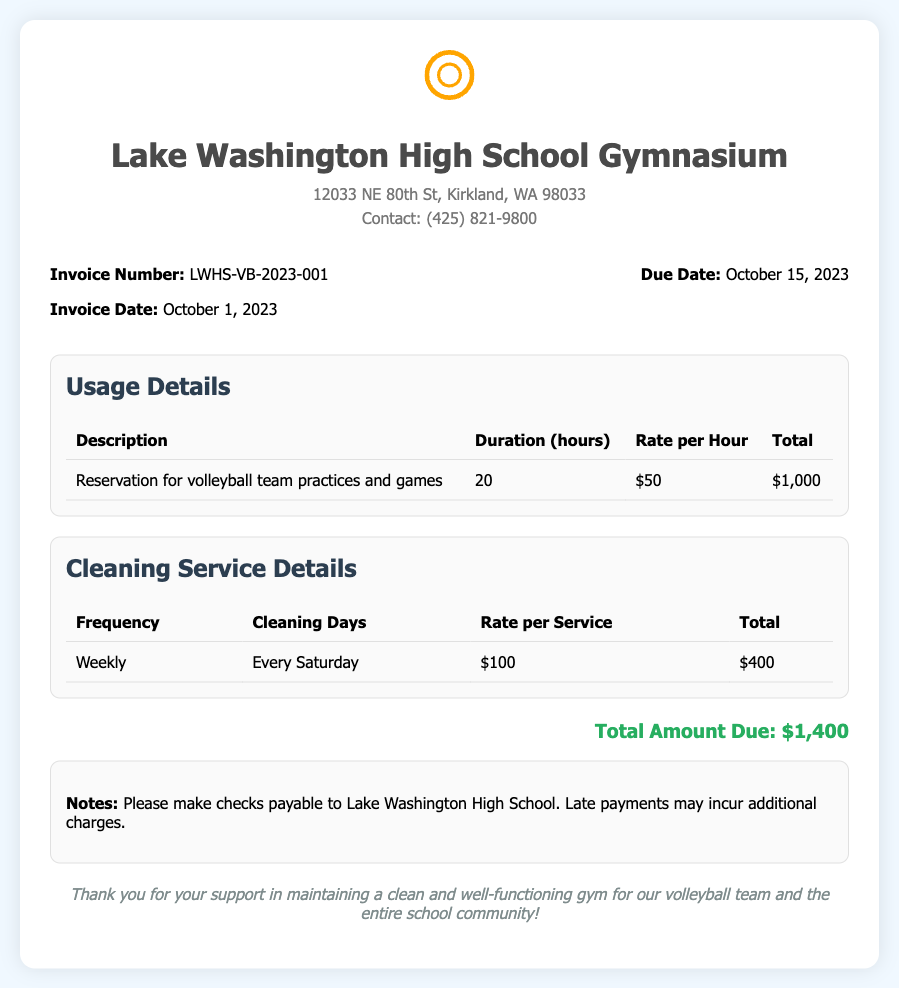what is the invoice number? The invoice number is found in the invoice details section, which states "Invoice Number: LWHS-VB-2023-001."
Answer: LWHS-VB-2023-001 what is the total amount due? The total amount due is summarized in the final section, stating "Total Amount Due: $1,400."
Answer: $1,400 how much is the rate per hour for usage? The rate per hour for usage is found in the usage details table, which indicates "Rate per Hour: $50."
Answer: $50 what is the cleaning service frequency? The cleaning service frequency is mentioned in the cleaning service details table, stating "Frequency: Weekly."
Answer: Weekly how many cleaning days are there? The number of cleaning days is specified in the cleaning service details table, stating "Cleaning Days: Every Saturday."
Answer: Every Saturday what is the duration of usage for practices? The duration for usage of the practices is listed as "Duration: 20 hours" in the usage details section.
Answer: 20 hours when is the due date for the invoice? The due date for the invoice is marked in the invoice details section as "Due Date: October 15, 2023."
Answer: October 15, 2023 how many times will the gym be cleaned in total? The cleaning service frequency indicates weekly cleaning for 4 weeks equating to 4 cleanings total.
Answer: 4 what should checks be made payable to? The notes section of the document specifies "Please make checks payable to Lake Washington High School."
Answer: Lake Washington High School 